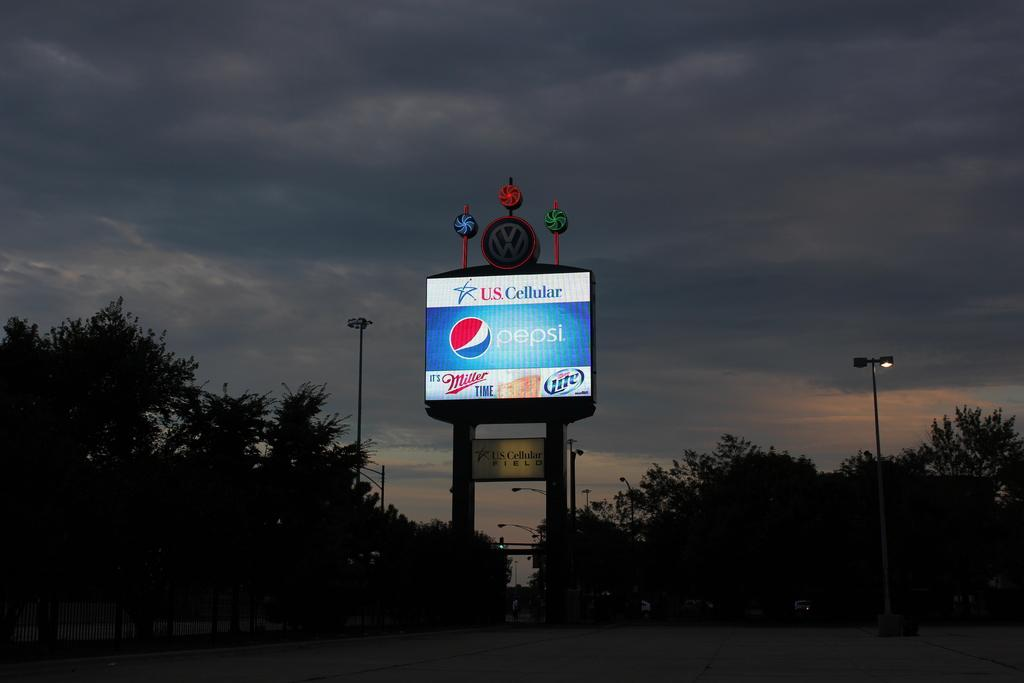<image>
Give a short and clear explanation of the subsequent image. An outside advertisement that says  U.S. Cellular with the Pepsi logo underneath and also It' s Miller Time. 